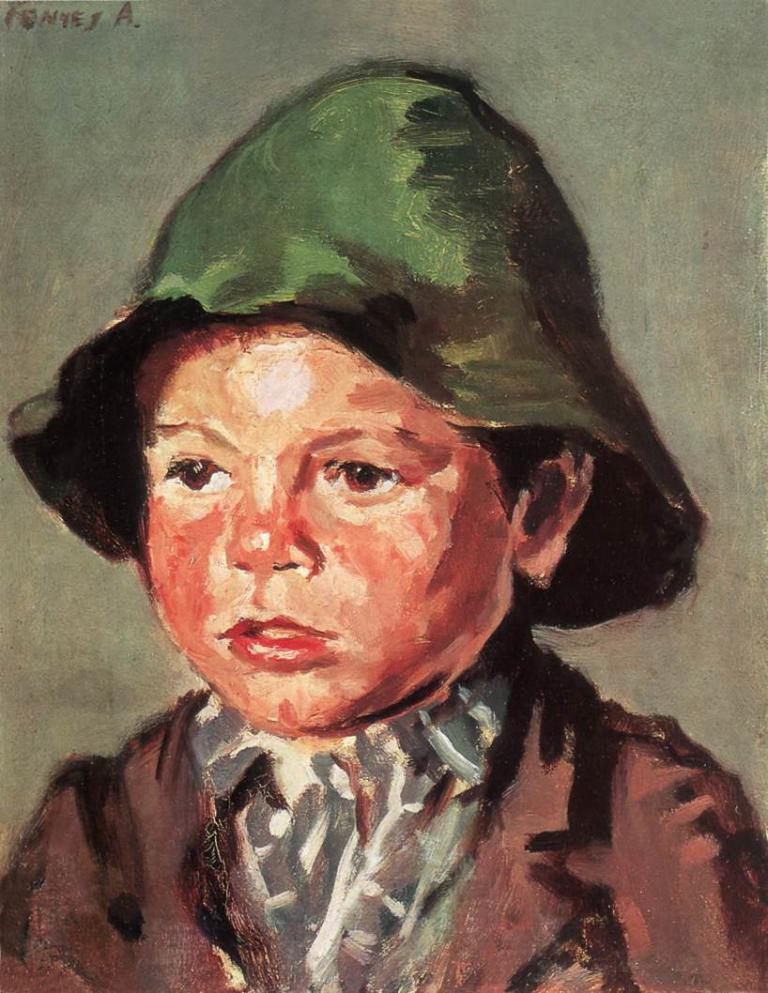What is depicted in the image? There is a painting of a person in the image. What is the person in the painting wearing? The person in the painting is wearing a cap. Is there any additional information or markings in the image? Yes, there is a watermark in the top left corner of the image. Can you describe the coastline visible in the image? There is no coastline visible in the image; it features a painting of a person wearing a cap. What type of street can be seen in the background of the image? There is no street visible in the image; it features a painting of a person wearing a cap. 